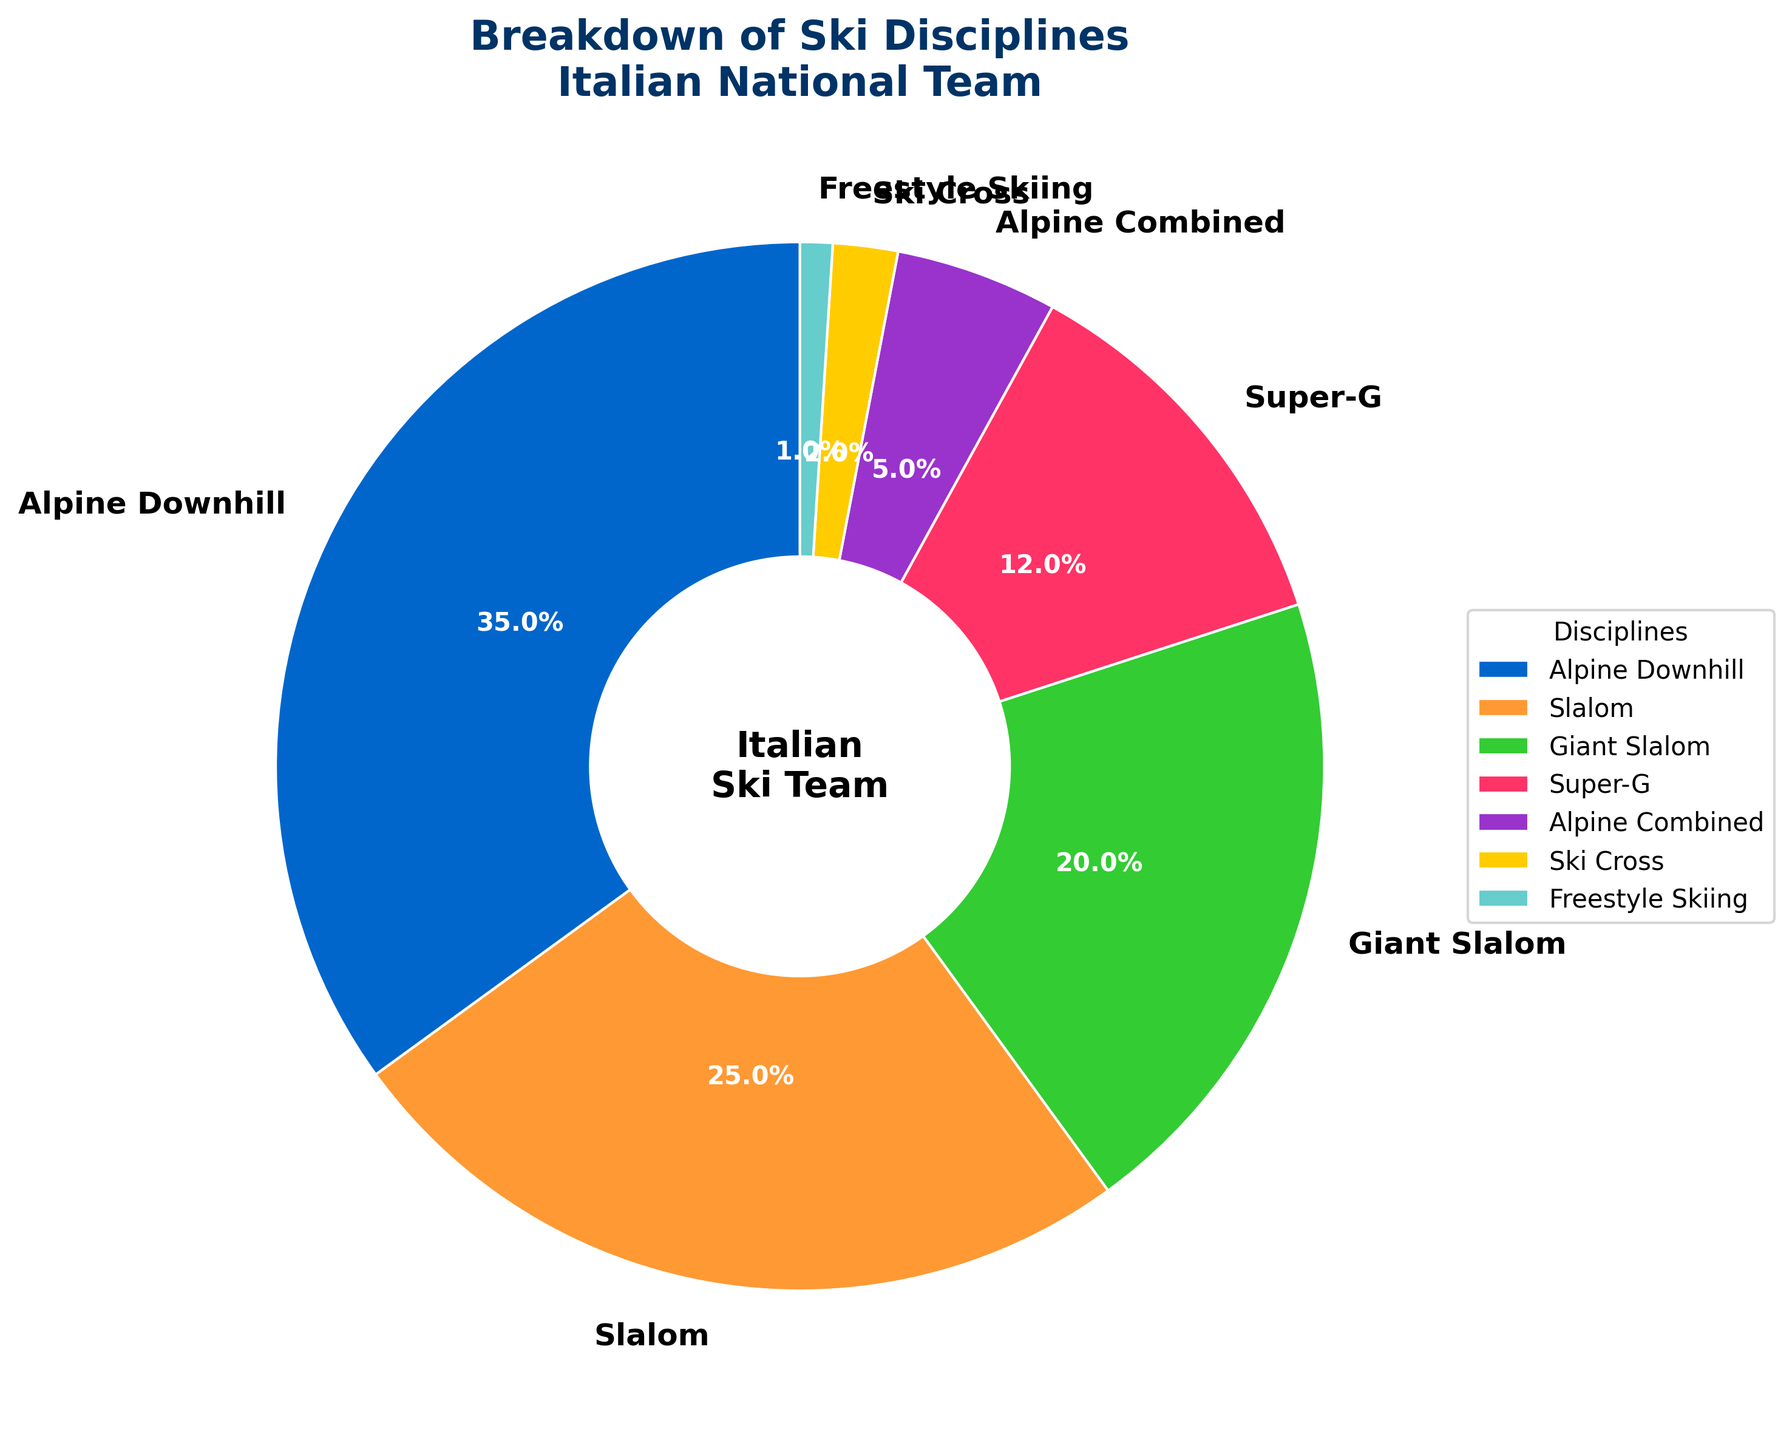What percentage of the Italian national team practices Slalom? The percentage of team members participating in each discipline is labeled on the pie chart. Locate the label for Slalom to find the percentage.
Answer: 25% Which discipline has the smallest proportion of team members? Look for the segment of the pie chart with the smallest slice and corresponding label.
Answer: Freestyle Skiing How much larger is the Alpine Downhill segment compared to the Super-G segment? Find and subtract the percentage of Super-G from the percentage of Alpine Downhill. Alpine Downhill is 35% and Super-G is 12%, thus 35% - 12%.
Answer: 23% Which disciplines together make up more than 50% of the chart? Sum the percentages of the largest segments until the total exceeds 50%. Alpine Downhill (35%) plus Slalom (25%) sums to 60%, which is more than 50%.
Answer: Alpine Downhill and Slalom What is the combined percentage of team members in Alpine Combined and Ski Cross? Add the percentages for Alpine Combined and Ski Cross. Alpine Combined is 5% and Ski Cross is 2%, so 5% + 2%.
Answer: 7% How does the proportion of Giant Slalom compare to that of Slalom? Compare the percentages for both disciplines mentioned on the chart. Giant Slalom is 20% and Slalom is 25%, Slalom is greater.
Answer: Slalom is greater Which color represents the Alpine Downhill segment? Identify the color corresponding to the Alpine Downhill label on the pie chart.
Answer: Blue Are there more team members practicing Super-G or Giant Slalom? Compare the percentages of team members in both disciplines. Super-G is 12% and Giant Slalom is 20%, Giant Slalom is more.
Answer: Giant Slalom What is the visual difference between the Slalom and Freestyle Skiing segments in the chart? Compare the size and color of the segments for Slalom and Freestyle Skiing. Slalom is a larger segment (one of the biggest), while Freestyle Skiing is the smallest.
Answer: Slalom's segment is larger If we combine Slalom, Giant Slalom, and Super-G, what percentage of the total team does this account for? Sum the percentages for Slalom (25%), Giant Slalom (20%), and Super-G (12%). The total is 25% + 20% + 12%.
Answer: 57% 